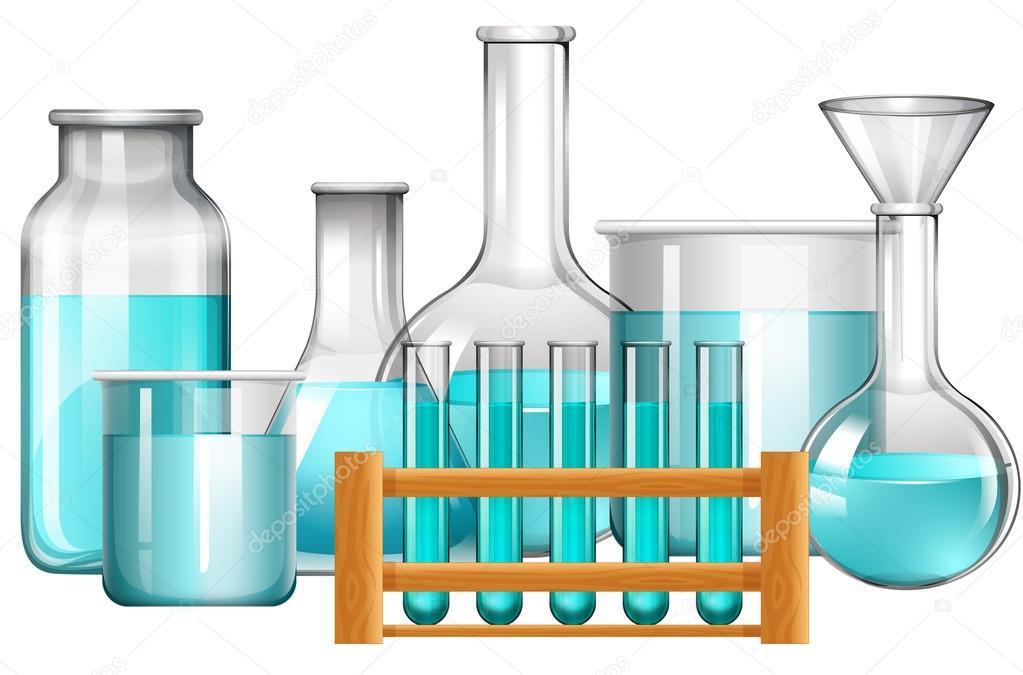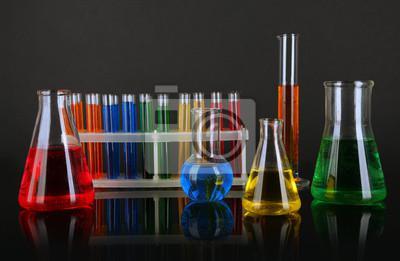The first image is the image on the left, the second image is the image on the right. Assess this claim about the two images: "In one image there are five test tubes.". Correct or not? Answer yes or no. Yes. The first image is the image on the left, the second image is the image on the right. Examine the images to the left and right. Is the description "There are five test tubes in the left image." accurate? Answer yes or no. Yes. 